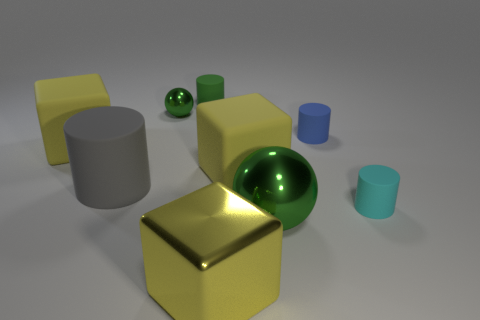Subtract all big matte blocks. How many blocks are left? 1 Subtract 1 cubes. How many cubes are left? 2 Subtract all green cylinders. How many cylinders are left? 3 Subtract all cubes. How many objects are left? 6 Subtract 1 blue cylinders. How many objects are left? 8 Subtract all yellow cylinders. Subtract all green spheres. How many cylinders are left? 4 Subtract all tiny blue cylinders. Subtract all big matte things. How many objects are left? 5 Add 9 green cylinders. How many green cylinders are left? 10 Add 3 large cyan matte cylinders. How many large cyan matte cylinders exist? 3 